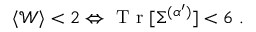<formula> <loc_0><loc_0><loc_500><loc_500>\begin{array} { r } { \langle \mathcal { W } \rangle < 2 \Leftrightarrow T r [ \Sigma ^ { ( \alpha ^ { \prime } ) } ] < 6 \, . } \end{array}</formula> 